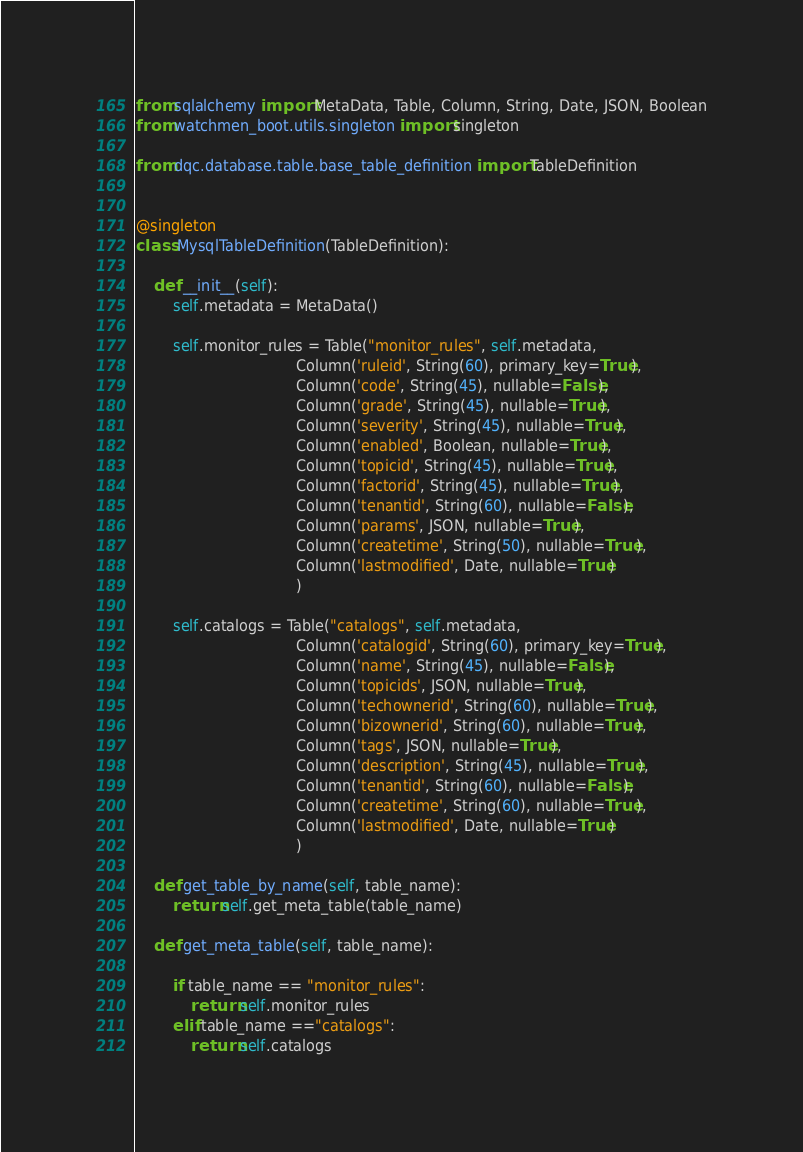Convert code to text. <code><loc_0><loc_0><loc_500><loc_500><_Python_>from sqlalchemy import MetaData, Table, Column, String, Date, JSON, Boolean
from watchmen_boot.utils.singleton import singleton

from dqc.database.table.base_table_definition import TableDefinition


@singleton
class MysqlTableDefinition(TableDefinition):

    def __init__(self):
        self.metadata = MetaData()

        self.monitor_rules = Table("monitor_rules", self.metadata,
                                   Column('ruleid', String(60), primary_key=True),
                                   Column('code', String(45), nullable=False),
                                   Column('grade', String(45), nullable=True),
                                   Column('severity', String(45), nullable=True),
                                   Column('enabled', Boolean, nullable=True),
                                   Column('topicid', String(45), nullable=True),
                                   Column('factorid', String(45), nullable=True),
                                   Column('tenantid', String(60), nullable=False),
                                   Column('params', JSON, nullable=True),
                                   Column('createtime', String(50), nullable=True),
                                   Column('lastmodified', Date, nullable=True)
                                   )

        self.catalogs = Table("catalogs", self.metadata,
                                   Column('catalogid', String(60), primary_key=True),
                                   Column('name', String(45), nullable=False),
                                   Column('topicids', JSON, nullable=True),
                                   Column('techownerid', String(60), nullable=True),
                                   Column('bizownerid', String(60), nullable=True),
                                   Column('tags', JSON, nullable=True),
                                   Column('description', String(45), nullable=True),
                                   Column('tenantid', String(60), nullable=False),
                                   Column('createtime', String(60), nullable=True),
                                   Column('lastmodified', Date, nullable=True)
                                   )

    def get_table_by_name(self, table_name):
        return self.get_meta_table(table_name)

    def get_meta_table(self, table_name):

        if table_name == "monitor_rules":
            return self.monitor_rules
        elif table_name =="catalogs":
            return self.catalogs

</code> 